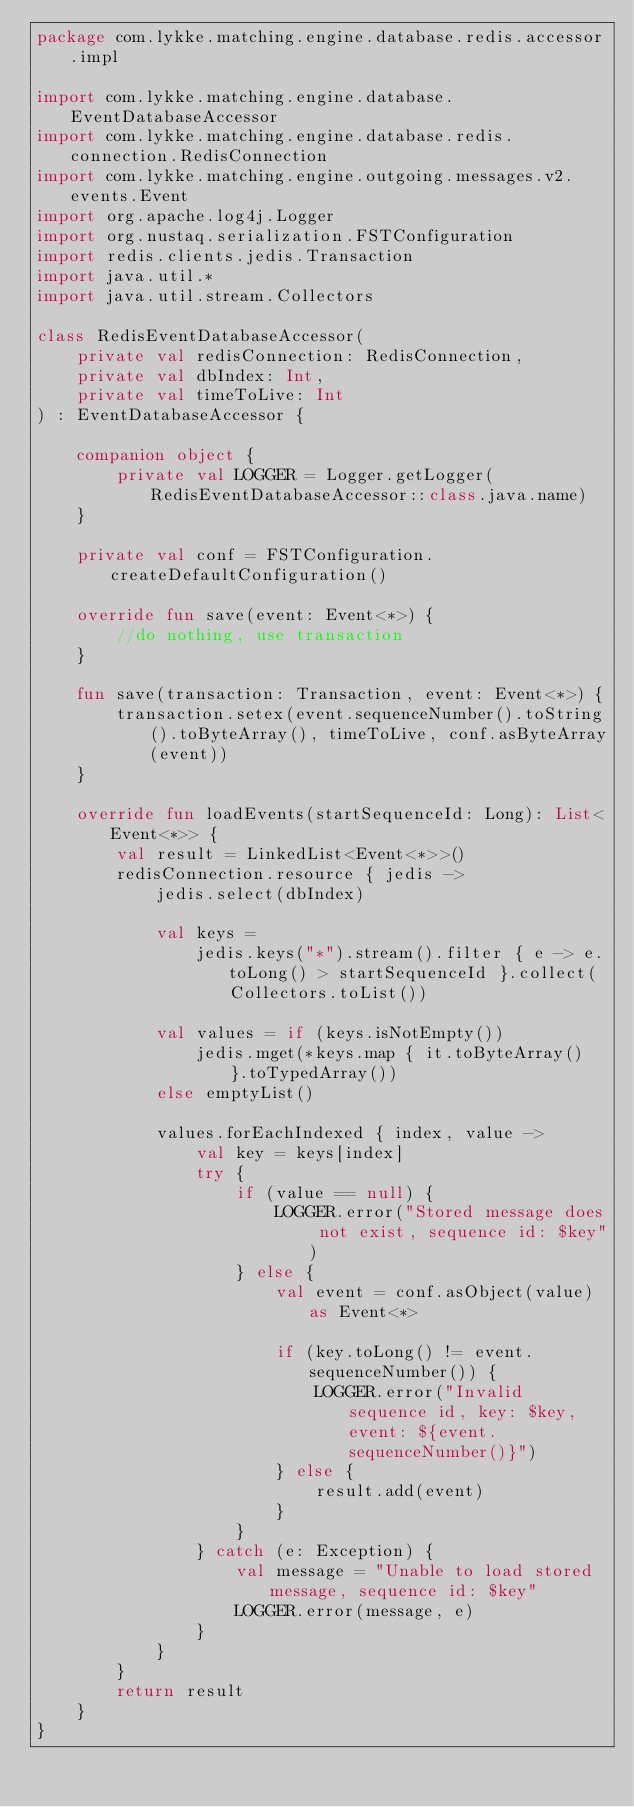Convert code to text. <code><loc_0><loc_0><loc_500><loc_500><_Kotlin_>package com.lykke.matching.engine.database.redis.accessor.impl

import com.lykke.matching.engine.database.EventDatabaseAccessor
import com.lykke.matching.engine.database.redis.connection.RedisConnection
import com.lykke.matching.engine.outgoing.messages.v2.events.Event
import org.apache.log4j.Logger
import org.nustaq.serialization.FSTConfiguration
import redis.clients.jedis.Transaction
import java.util.*
import java.util.stream.Collectors

class RedisEventDatabaseAccessor(
    private val redisConnection: RedisConnection,
    private val dbIndex: Int,
    private val timeToLive: Int
) : EventDatabaseAccessor {

    companion object {
        private val LOGGER = Logger.getLogger(RedisEventDatabaseAccessor::class.java.name)
    }

    private val conf = FSTConfiguration.createDefaultConfiguration()

    override fun save(event: Event<*>) {
        //do nothing, use transaction
    }

    fun save(transaction: Transaction, event: Event<*>) {
        transaction.setex(event.sequenceNumber().toString().toByteArray(), timeToLive, conf.asByteArray(event))
    }

    override fun loadEvents(startSequenceId: Long): List<Event<*>> {
        val result = LinkedList<Event<*>>()
        redisConnection.resource { jedis ->
            jedis.select(dbIndex)

            val keys =
                jedis.keys("*").stream().filter { e -> e.toLong() > startSequenceId }.collect(Collectors.toList())

            val values = if (keys.isNotEmpty())
                jedis.mget(*keys.map { it.toByteArray() }.toTypedArray())
            else emptyList()

            values.forEachIndexed { index, value ->
                val key = keys[index]
                try {
                    if (value == null) {
                        LOGGER.error("Stored message does not exist, sequence id: $key")
                    } else {
                        val event = conf.asObject(value) as Event<*>

                        if (key.toLong() != event.sequenceNumber()) {
                            LOGGER.error("Invalid sequence id, key: $key, event: ${event.sequenceNumber()}")
                        } else {
                            result.add(event)
                        }
                    }
                } catch (e: Exception) {
                    val message = "Unable to load stored message, sequence id: $key"
                    LOGGER.error(message, e)
                }
            }
        }
        return result
    }
}</code> 